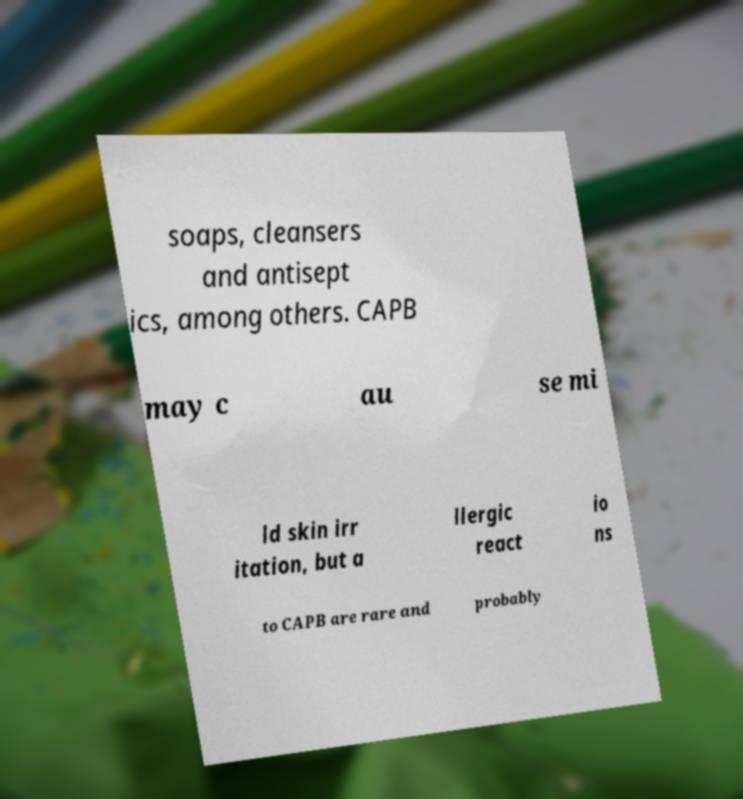For documentation purposes, I need the text within this image transcribed. Could you provide that? soaps, cleansers and antisept ics, among others. CAPB may c au se mi ld skin irr itation, but a llergic react io ns to CAPB are rare and probably 